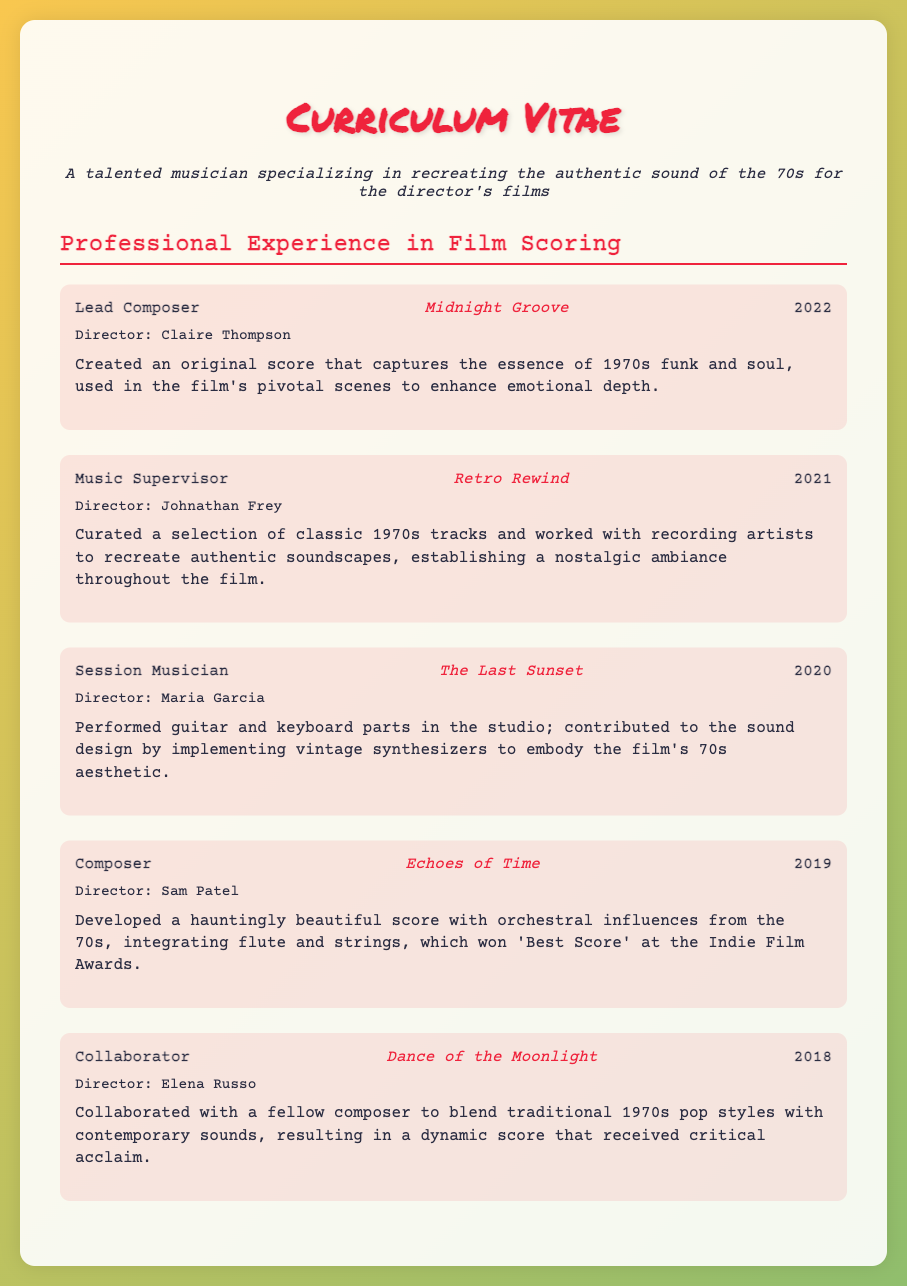what is the position of the individual for the project "Midnight Groove"? The document specifies that the individual is the Lead Composer for this project.
Answer: Lead Composer who directed the film "Echoes of Time"? The director mentioned for "Echoes of Time" is Sam Patel.
Answer: Sam Patel in what year was "Retro Rewind" released? This film was released in the year 2021 as stated in the document.
Answer: 2021 what type of music did the individual create for the film "Midnight Groove"? The description indicates that the score captures the essence of 1970s funk and soul.
Answer: 1970s funk and soul which award did the score for "Echoes of Time" win? The document states that it won 'Best Score' at the Indie Film Awards.
Answer: Best Score how many projects are listed in the Professional Experience section? The document lists five distinct projects in the Professional Experience section.
Answer: five what is the main contribution of the individual in "The Last Sunset"? The individual performed guitar and keyboard parts in the studio.
Answer: performed guitar and keyboard parts which film involved collaboration with another composer? The film "Dance of the Moonlight" involved collaboration with a fellow composer.
Answer: Dance of the Moonlight what musical instruments did the individual use in "The Last Sunset"? The individual used guitar and keyboard parts as stated in the description.
Answer: guitar and keyboard 